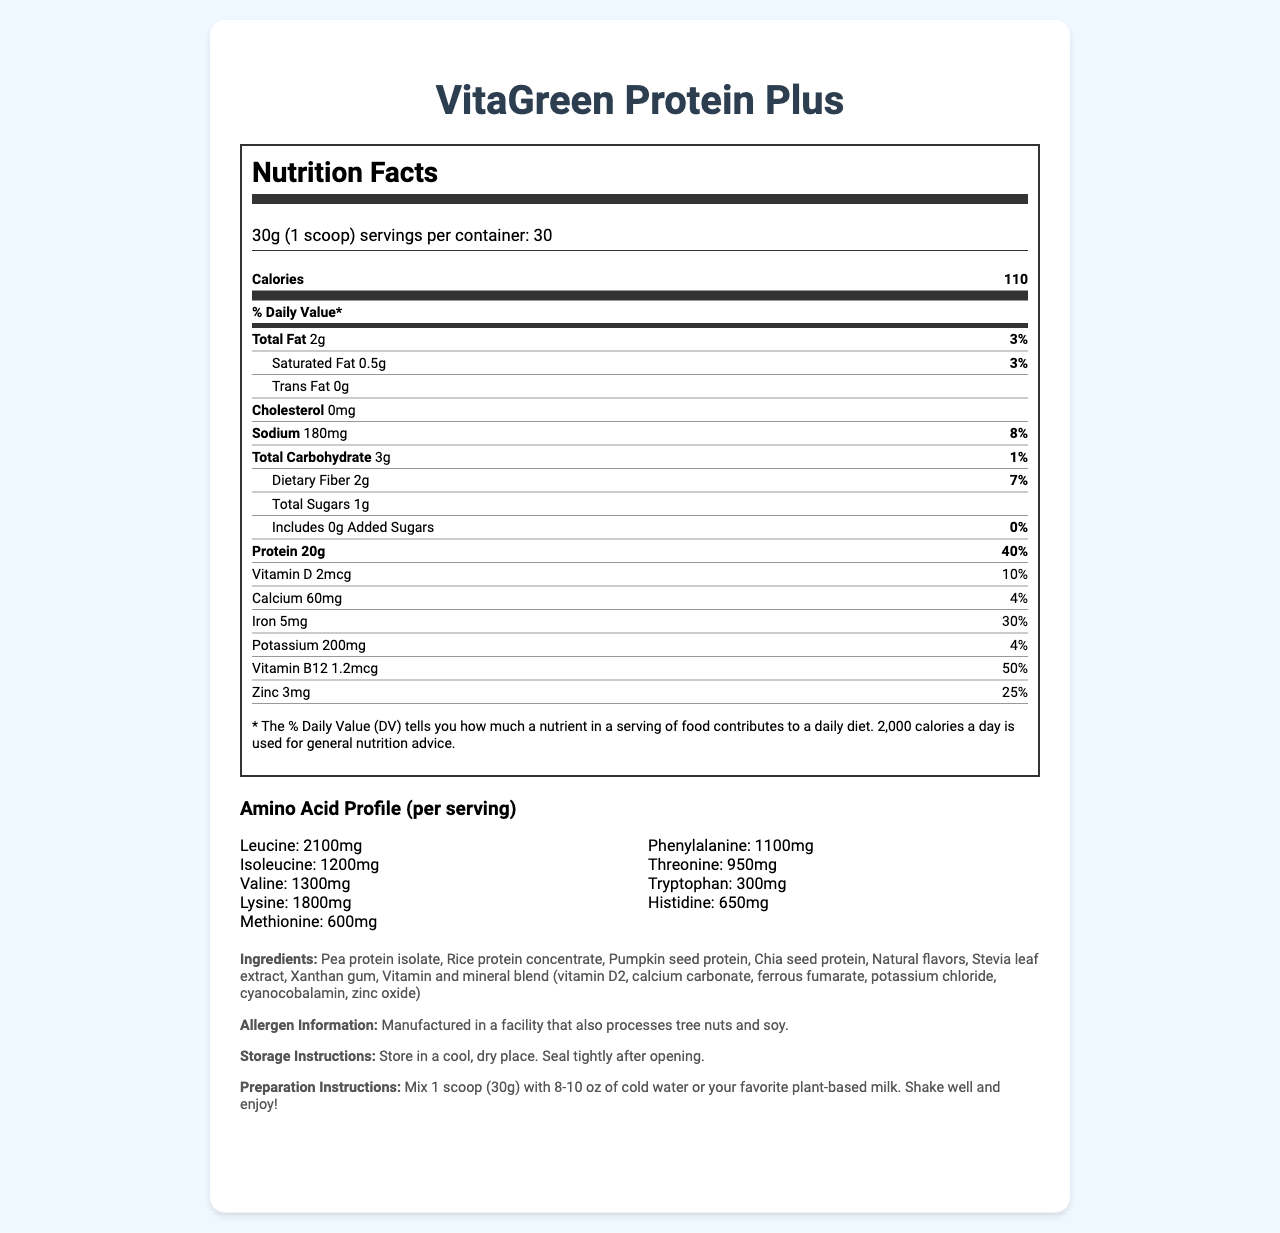what is the serving size of VitaGreen Protein Plus? The serving size is clearly mentioned in the document as 30g, equivalent to 1 scoop.
Answer: 30g (1 scoop) how many servings are there per container? The document states that there are 30 servings per container.
Answer: 30 how many calories are in one serving? The nutrition label shows that one serving of the product contains 110 calories.
Answer: 110 how much protein does one serving contain? According to the nutrition label, one serving contains 20g of protein.
Answer: 20g how much dietary fiber is in one serving, and what percentage of the daily value does it represent? The nutrition label indicates that one serving has 2g of dietary fiber, which represents 7% of the daily value.
Answer: 2g, 7% which of the following is NOT a source of protein in the product? A. Pea protein isolate B. Rice protein concentrate C. Chia seed protein D. Soy protein The ingredients list includes Pea protein isolate, Rice protein concentrate, and Chia seed protein, but not Soy protein.
Answer: D. Soy protein What percentage of the daily value for Vitamin B12 is provided per serving? A. 10% B. 25% C. 50% D. 100% The nutrition label specifies that one serving provides 50% of the daily value for Vitamin B12.
Answer: C. 50% Does the product contain any added sugars? The nutrition label states that there are 0g of added sugars in the product.
Answer: No Does the product include any common allergens? The document states that the product is manufactured in a facility that processes tree nuts and soy, which are common allergens.
Answer: Yes Can you summarize the main nutritional benefits of VitaGreen Protein Plus? The summary captures the key highlights of the nutritional benefits, including protein content, essential micronutrients, target audience, and certifications.
Answer: VitaGreen Protein Plus is a plant-based protein powder designed to provide a complete amino acid profile comparable to whey protein. Each 30g serving contains 20g of protein and essential micronutrients such as Vitamin B12, zinc, iron, and calcium. It is suitable for vegan and vegetarian athletes and those with dairy sensitivities. The product is also Non-GMO Project Verified, Vegan, and Gluten-Free. What is the price of VitaGreen Protein Plus? The document does not provide any information on the pricing of the product.
Answer: Not enough information 